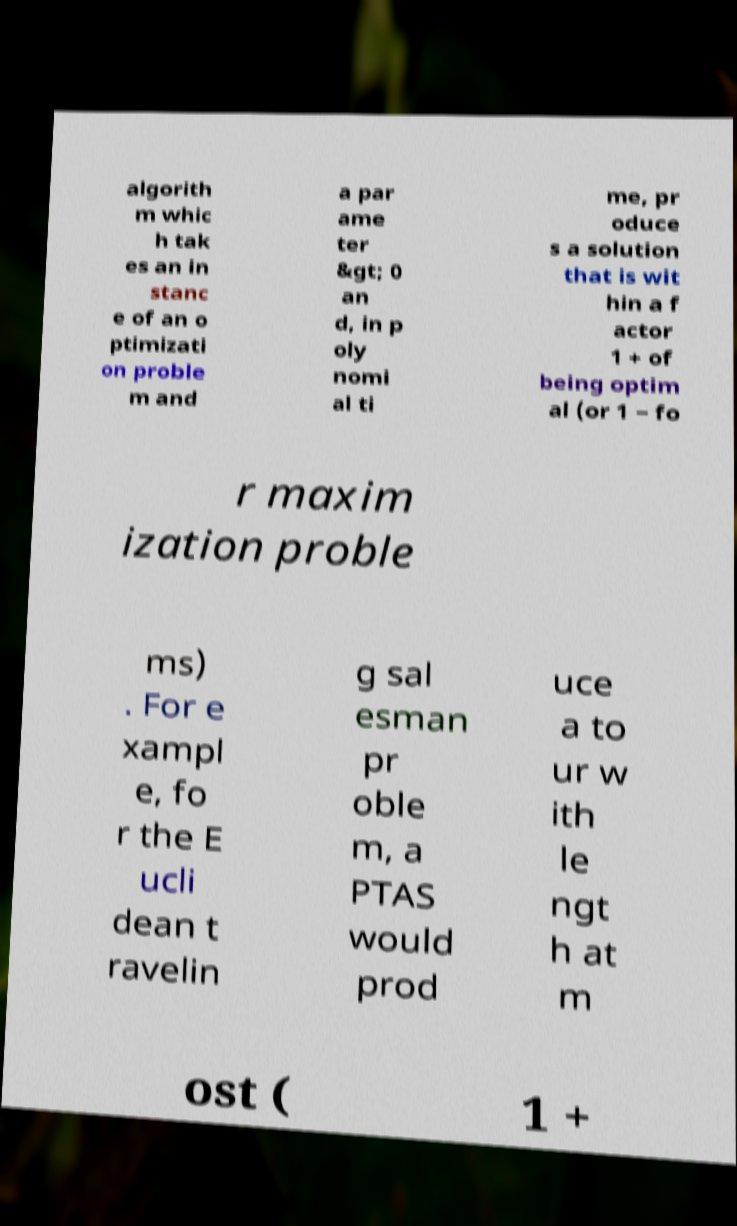For documentation purposes, I need the text within this image transcribed. Could you provide that? algorith m whic h tak es an in stanc e of an o ptimizati on proble m and a par ame ter &gt; 0 an d, in p oly nomi al ti me, pr oduce s a solution that is wit hin a f actor 1 + of being optim al (or 1 − fo r maxim ization proble ms) . For e xampl e, fo r the E ucli dean t ravelin g sal esman pr oble m, a PTAS would prod uce a to ur w ith le ngt h at m ost ( 1 + 